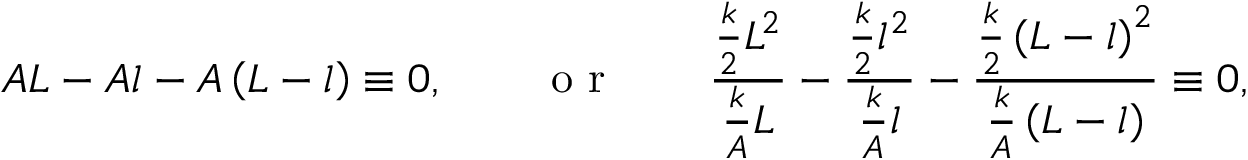Convert formula to latex. <formula><loc_0><loc_0><loc_500><loc_500>A L - A l - A \left ( L - l \right ) \equiv 0 , \quad o r \quad \frac { \frac { k } { 2 } L ^ { 2 } } { \frac { k } { A } L } - \frac { \frac { k } { 2 } l ^ { 2 } } { \frac { k } { A } l } - \frac { \frac { k } { 2 } \left ( L - l \right ) ^ { 2 } } { \frac { k } { A } \left ( L - l \right ) } \equiv 0 ,</formula> 